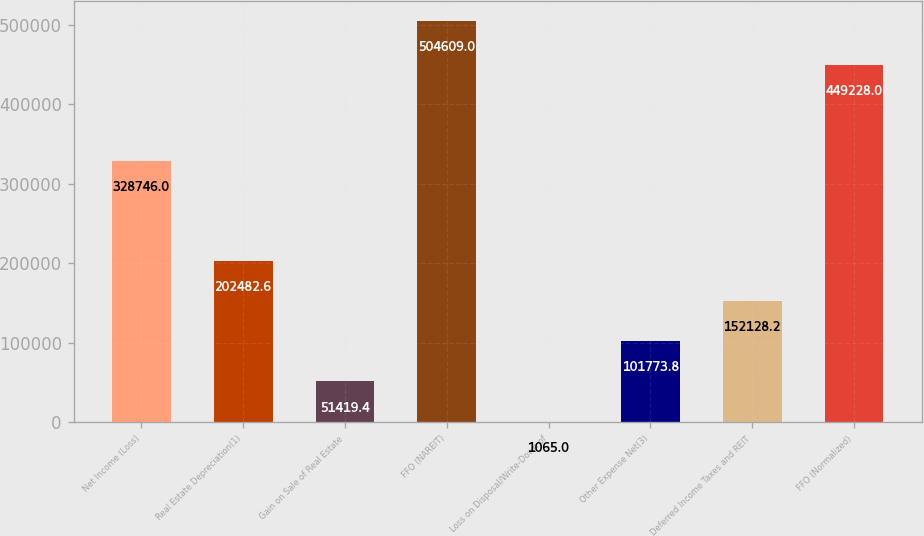<chart> <loc_0><loc_0><loc_500><loc_500><bar_chart><fcel>Net Income (Loss)<fcel>Real Estate Depreciation(1)<fcel>Gain on Sale of Real Estate<fcel>FFO (NAREIT)<fcel>Loss on Disposal/Write-Down of<fcel>Other Expense Net(3)<fcel>Deferred Income Taxes and REIT<fcel>FFO (Normalized)<nl><fcel>328746<fcel>202483<fcel>51419.4<fcel>504609<fcel>1065<fcel>101774<fcel>152128<fcel>449228<nl></chart> 